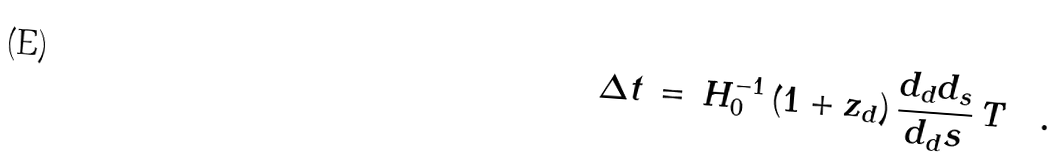<formula> <loc_0><loc_0><loc_500><loc_500>\Delta t \, = \, H _ { 0 } ^ { - 1 } \, ( 1 + z _ { d } ) \, \frac { d _ { d } d _ { s } } { d _ { d } s } \, T \quad .</formula> 